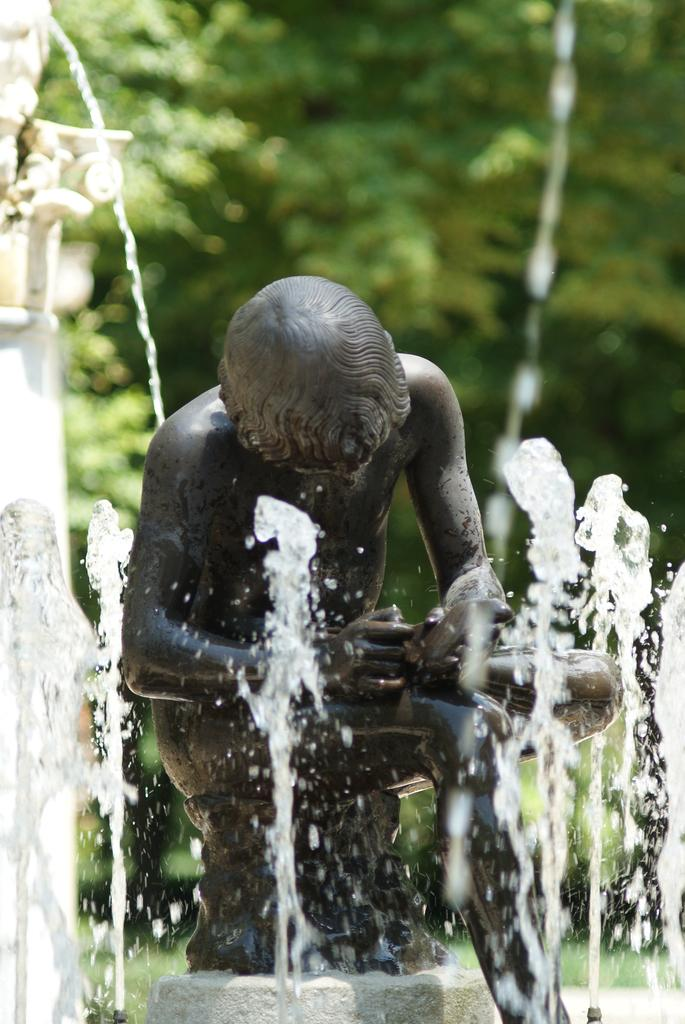What is the main subject in the image? There is a statue in the image. What other features can be seen in the image? There is a fountain and trees visible in the image. Where are the objects located in the image? The objects are on the left side of the image. What type of worm can be seen in the image? There are no worms present in the image. 